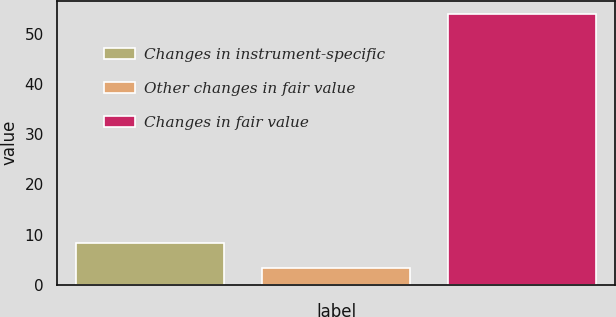Convert chart to OTSL. <chart><loc_0><loc_0><loc_500><loc_500><bar_chart><fcel>Changes in instrument-specific<fcel>Other changes in fair value<fcel>Changes in fair value<nl><fcel>8.34<fcel>3.27<fcel>54<nl></chart> 